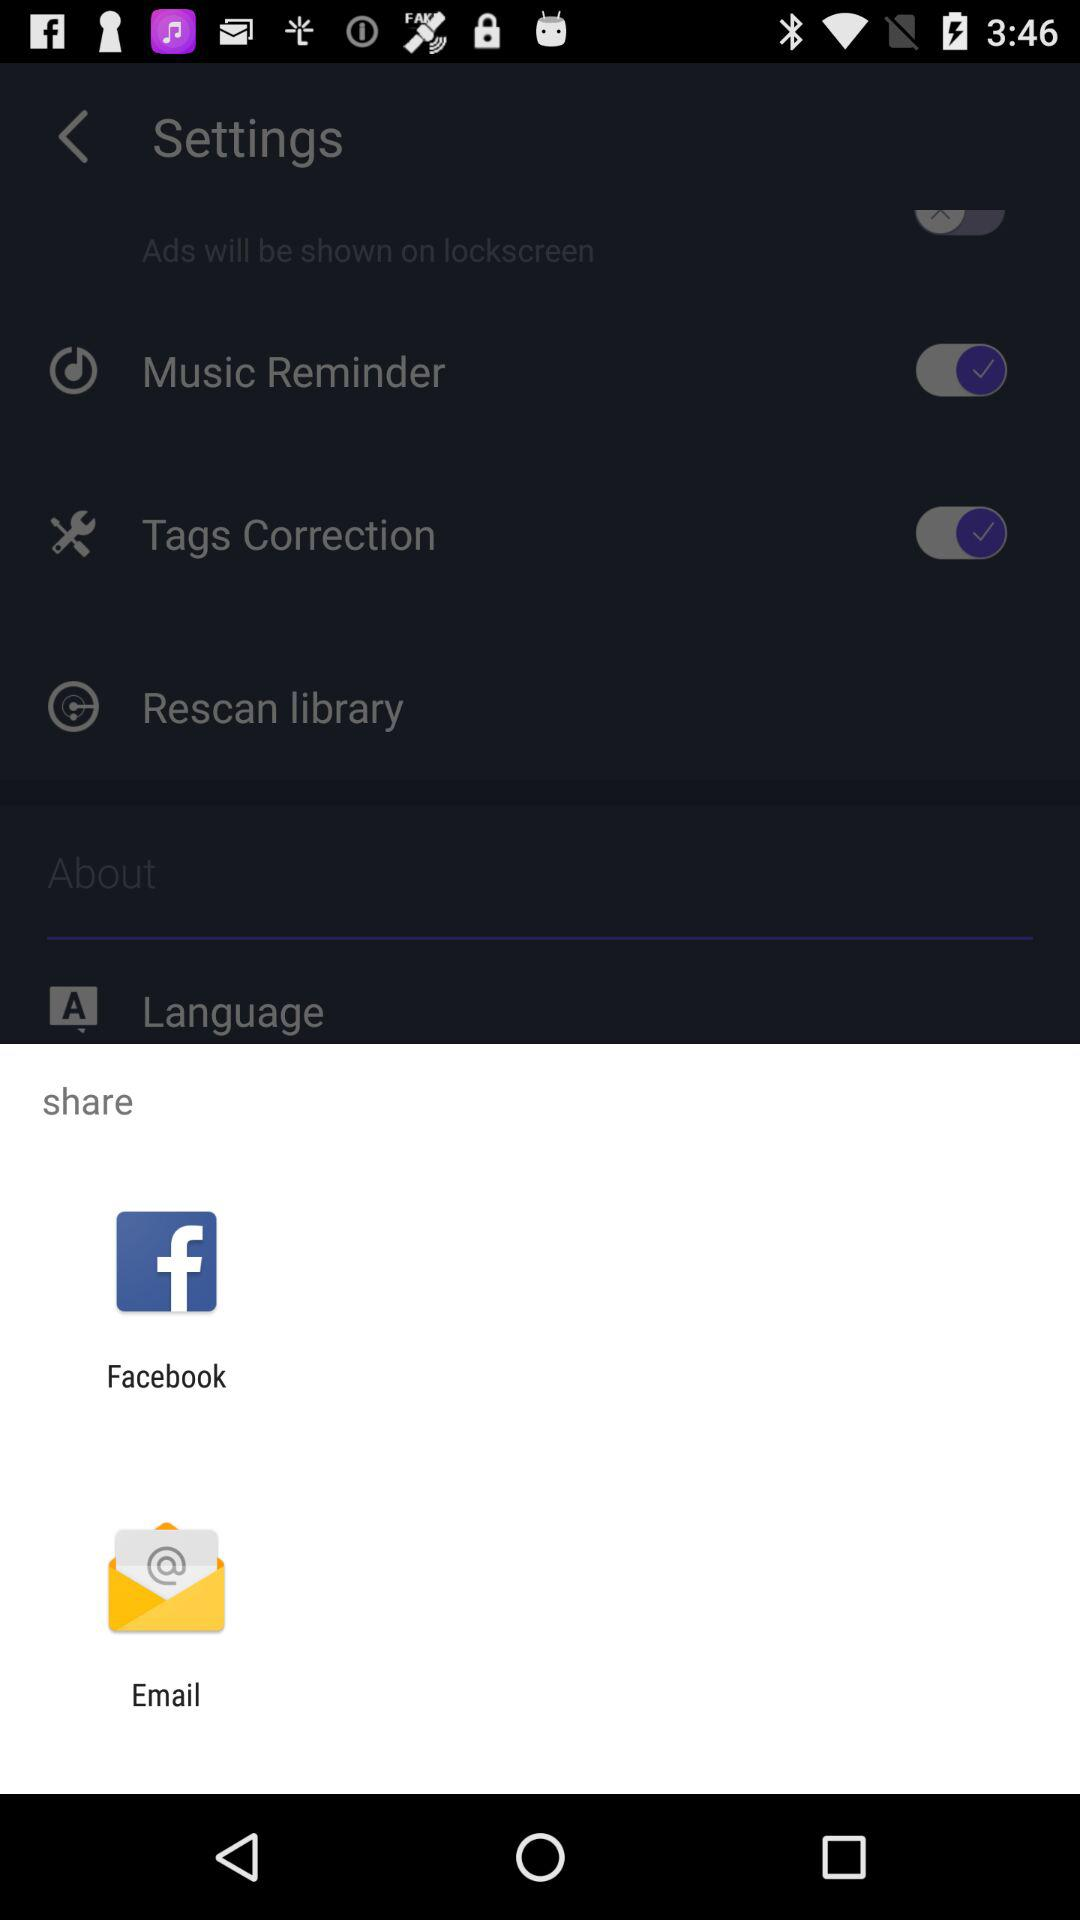What are the options to share? You can share it with "Facebook" and "Email". 